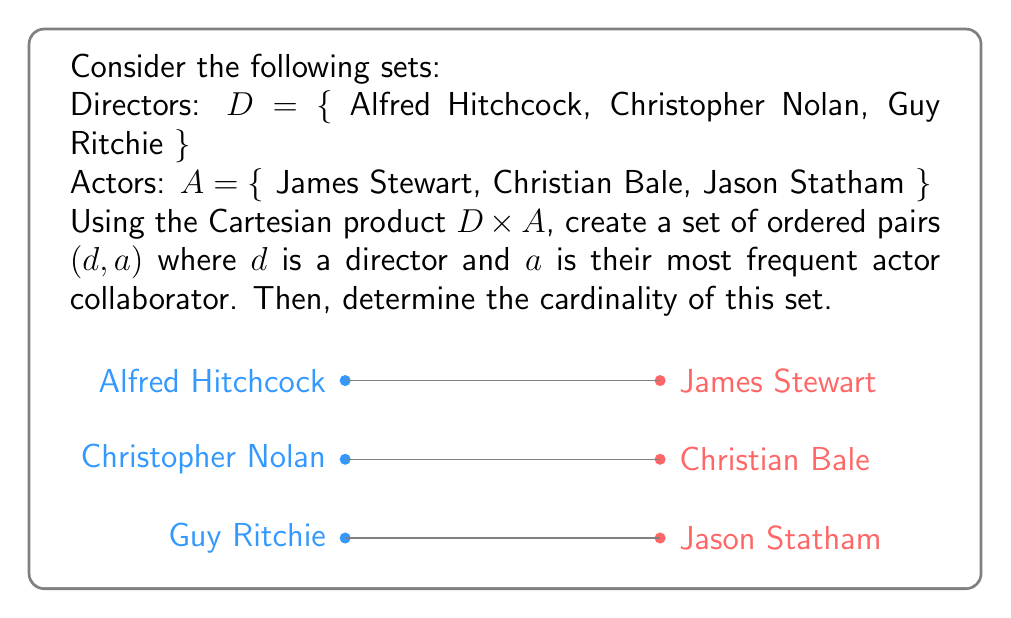Solve this math problem. Let's approach this step-by-step:

1) First, we need to identify the most frequent actor collaborator for each director:
   - Alfred Hitchcock frequently collaborated with James Stewart
   - Christopher Nolan often works with Christian Bale
   - Guy Ritchie has frequently cast Jason Statham

2) Now, we can create the Cartesian product $D \times A$:
   $$D \times A = \{(d, a) | d \in D, a \in A\}$$

3) From this Cartesian product, we select only the pairs that represent the director-actor collaborations we identified:
   $$\{(\text{Alfred Hitchcock}, \text{James Stewart}), (\text{Christopher Nolan}, \text{Christian Bale}), (\text{Guy Ritchie}, \text{Jason Statham})\}$$

4) To determine the cardinality of this set, we simply count the number of ordered pairs in our set.

5) There are 3 ordered pairs in our set, corresponding to the 3 director-actor collaborations we identified.

Therefore, the cardinality of our set of director-actor collaborations is 3.
Answer: 3 